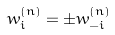Convert formula to latex. <formula><loc_0><loc_0><loc_500><loc_500>w _ { i } ^ { ( n ) } = \pm w _ { - i } ^ { ( n ) }</formula> 